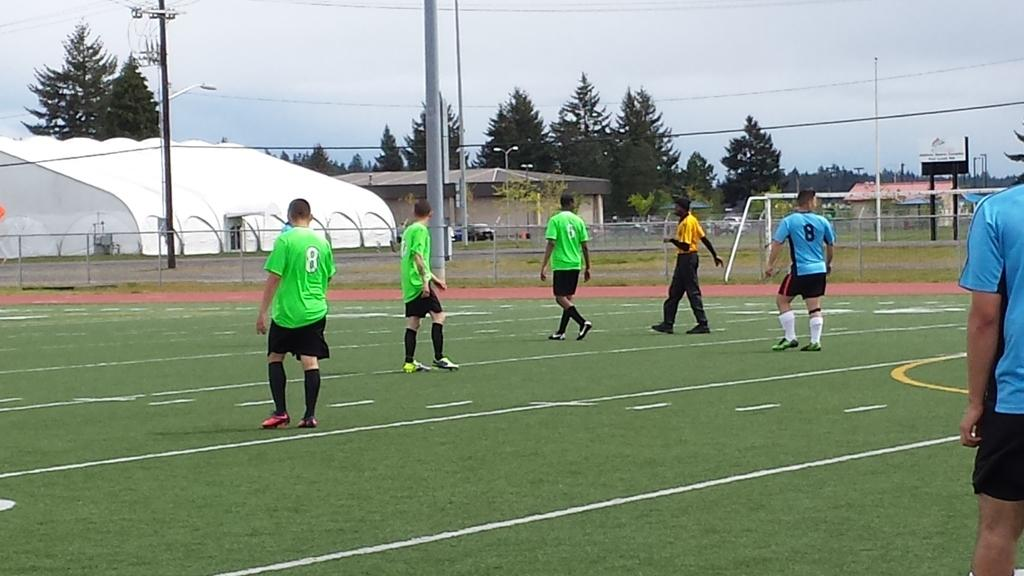<image>
Write a terse but informative summary of the picture. Soccer player jerseys that have number eight and number six on the back 